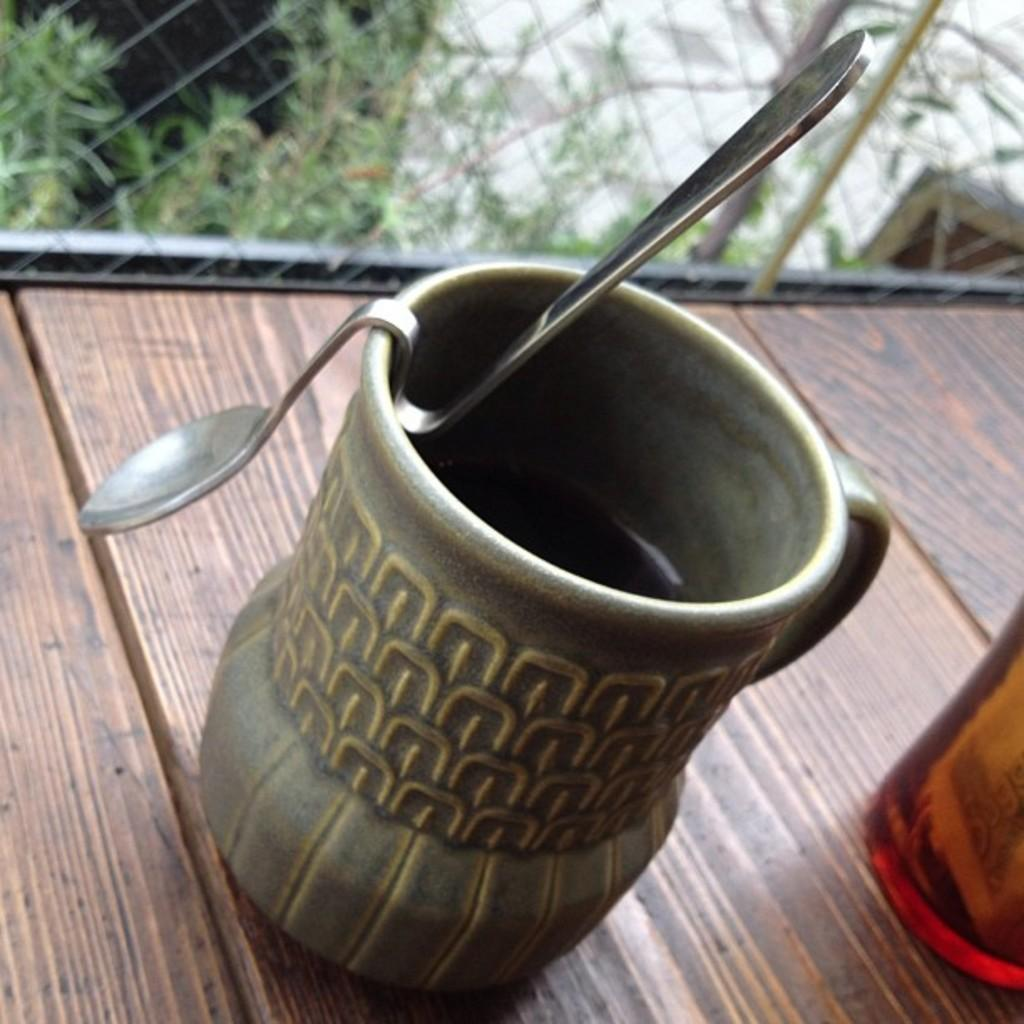What utensil is visible in the image? There is a spoon in the image. What object is the spoon placed near? There is a jar in the image, and the spoon and jar are placed on a table. What can be seen in the background of the image? There is fencing and plants in the background of the image. How many clovers are growing on the table in the image? There are no clovers present on the table in the image. 